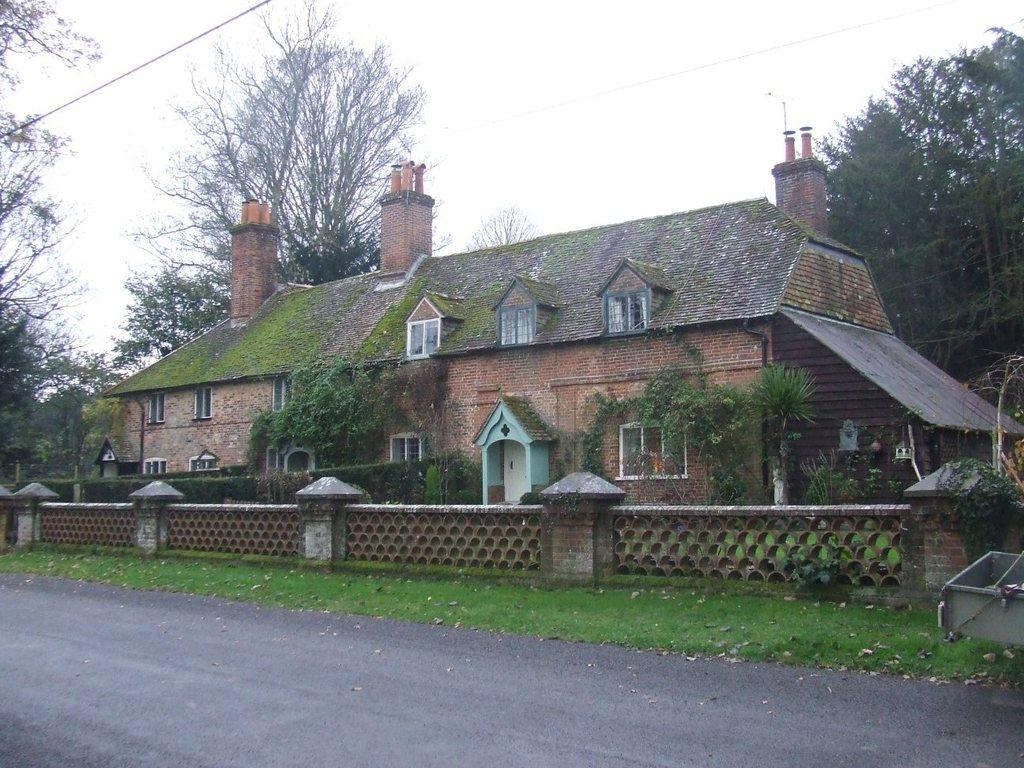What is the main structure in the middle of the picture? There is a building in the middle of the picture. What is located in front of the building? There is a wall and a road in front of the building. What can be seen in the background of the picture? There are trees and the sky visible in the background of the picture. What type of boat can be seen sailing in the picture? There is no boat present in the picture; it features a building, wall, road, trees, and sky. 